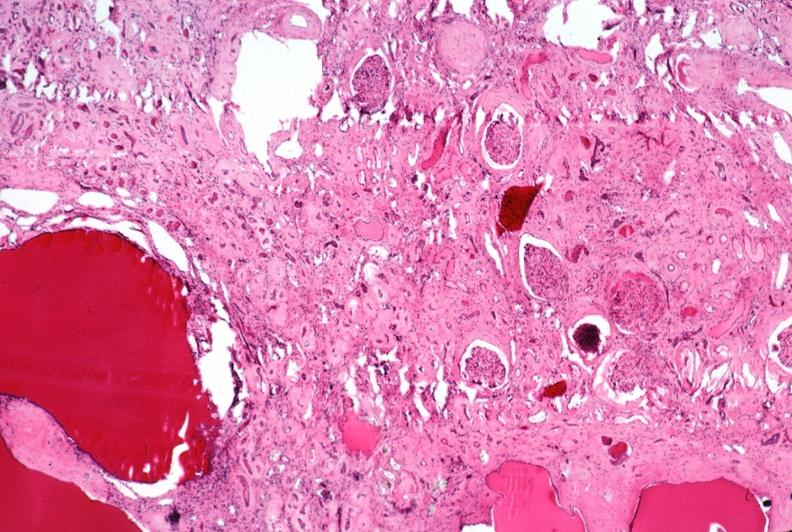where is this?
Answer the question using a single word or phrase. Urinary 